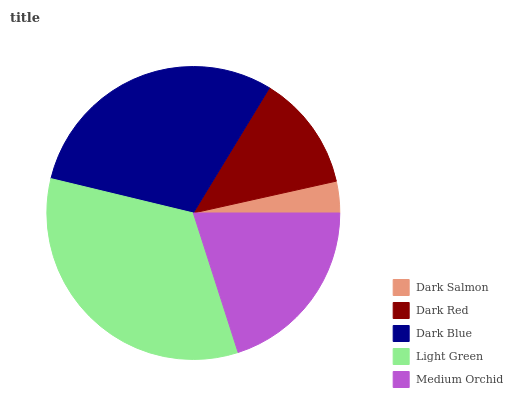Is Dark Salmon the minimum?
Answer yes or no. Yes. Is Light Green the maximum?
Answer yes or no. Yes. Is Dark Red the minimum?
Answer yes or no. No. Is Dark Red the maximum?
Answer yes or no. No. Is Dark Red greater than Dark Salmon?
Answer yes or no. Yes. Is Dark Salmon less than Dark Red?
Answer yes or no. Yes. Is Dark Salmon greater than Dark Red?
Answer yes or no. No. Is Dark Red less than Dark Salmon?
Answer yes or no. No. Is Medium Orchid the high median?
Answer yes or no. Yes. Is Medium Orchid the low median?
Answer yes or no. Yes. Is Dark Red the high median?
Answer yes or no. No. Is Dark Blue the low median?
Answer yes or no. No. 